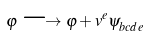Convert formula to latex. <formula><loc_0><loc_0><loc_500><loc_500>\varphi \longrightarrow \varphi + v ^ { e } \psi _ { b c d e } ^ { \quad \ \ }</formula> 